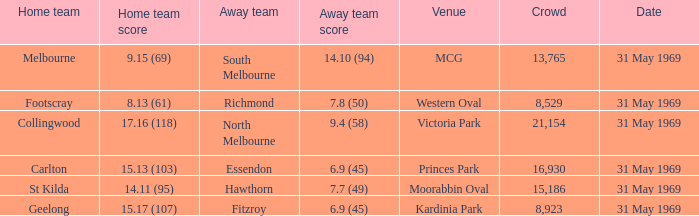What was the highest crowd in Victoria Park? 21154.0. 